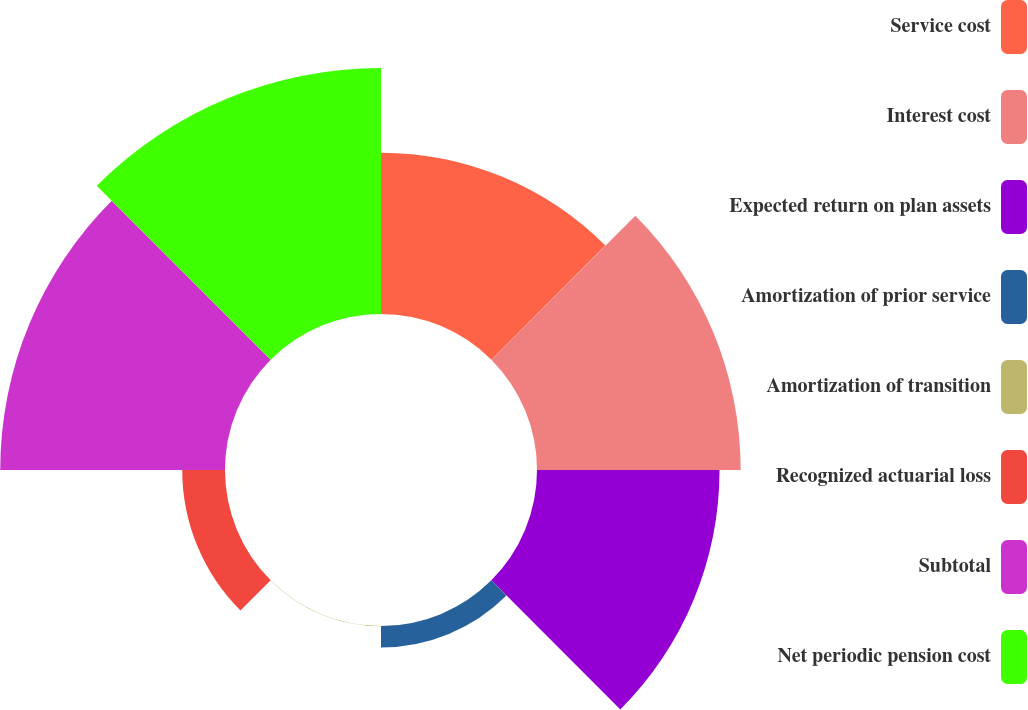<chart> <loc_0><loc_0><loc_500><loc_500><pie_chart><fcel>Service cost<fcel>Interest cost<fcel>Expected return on plan assets<fcel>Amortization of prior service<fcel>Amortization of transition<fcel>Recognized actuarial loss<fcel>Subtotal<fcel>Net periodic pension cost<nl><fcel>14.9%<fcel>18.81%<fcel>16.86%<fcel>1.98%<fcel>0.03%<fcel>3.95%<fcel>20.76%<fcel>22.72%<nl></chart> 